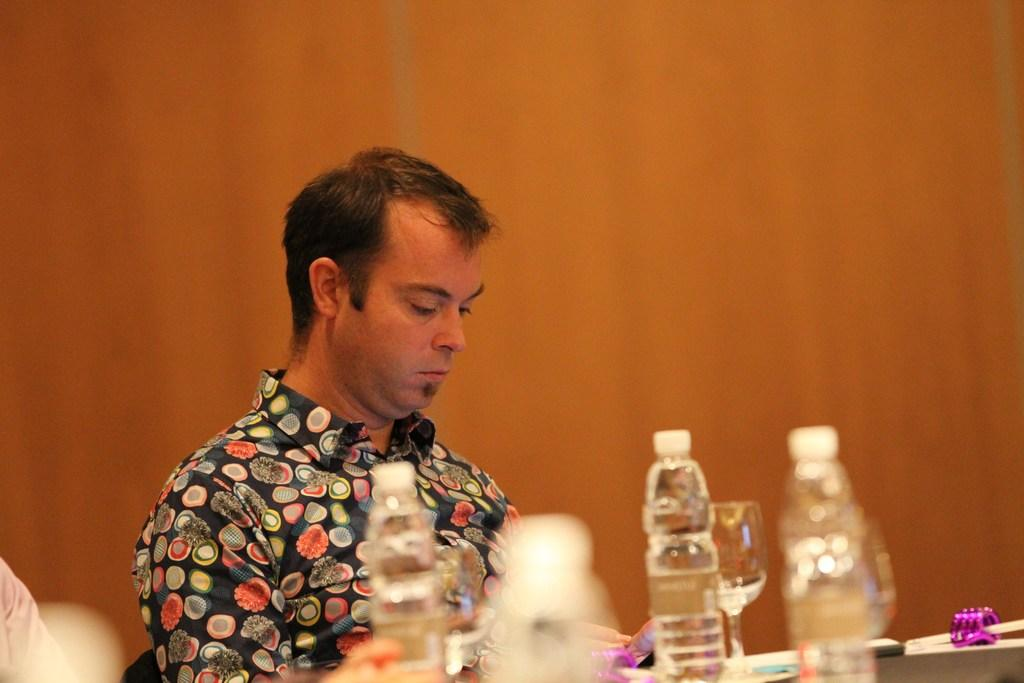What is the person in the image doing? The person is sitting in the image. Where is the person located in relation to the table? The person is in front of a table. What items can be seen on the table? There are water bottles and a glass on the table. What color is the crayon being used by the person in the image? There is no crayon present in the image. What type of journey is the person embarking on in the image? The image does not depict a journey or any indication of travel. 